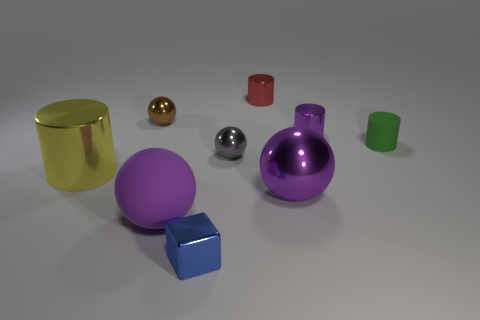What number of other objects are there of the same color as the big cylinder?
Give a very brief answer. 0. There is a tiny metallic thing that is behind the brown sphere; is its shape the same as the yellow metal object?
Ensure brevity in your answer.  Yes. What color is the big metallic object that is the same shape as the green matte thing?
Make the answer very short. Yellow. There is a purple object that is the same shape as the yellow shiny thing; what size is it?
Your answer should be compact. Small. What is the cylinder that is both to the right of the yellow cylinder and in front of the small purple shiny cylinder made of?
Offer a terse response. Rubber. Is the color of the large metallic thing right of the tiny blue cube the same as the large cylinder?
Provide a short and direct response. No. There is a big metal cylinder; does it have the same color as the sphere that is behind the tiny purple cylinder?
Provide a short and direct response. No. There is a tiny green object; are there any large things behind it?
Provide a succinct answer. No. Is the red cylinder made of the same material as the green object?
Offer a very short reply. No. What material is the green cylinder that is the same size as the blue thing?
Ensure brevity in your answer.  Rubber. 